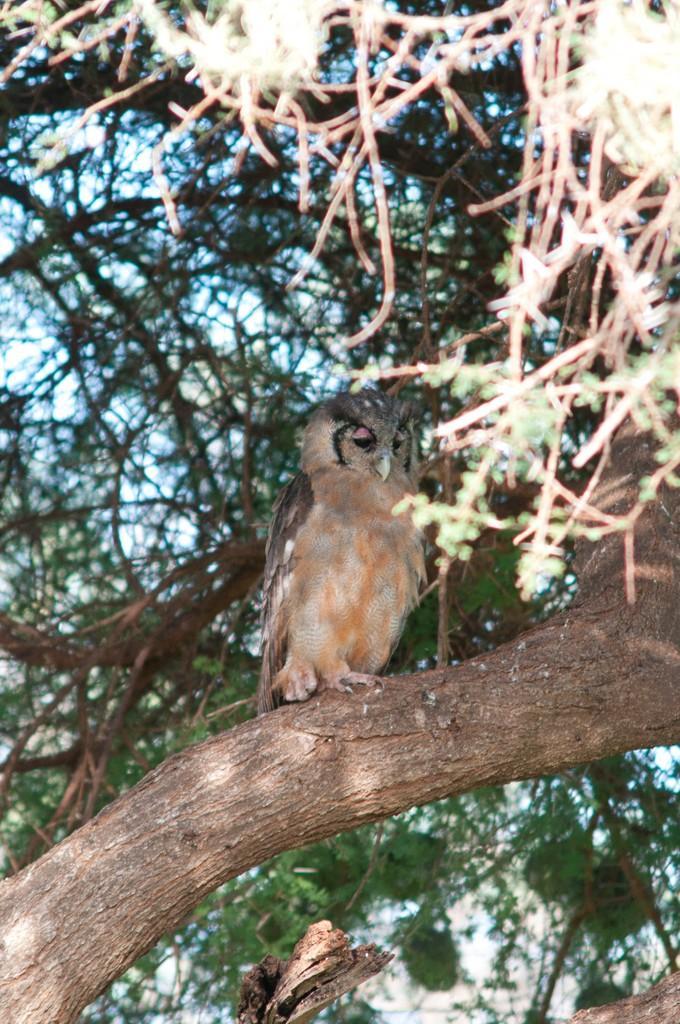How would you summarize this image in a sentence or two? In this image there is an owl on the branch of a tree, behind the owl there are leaves and branches. 